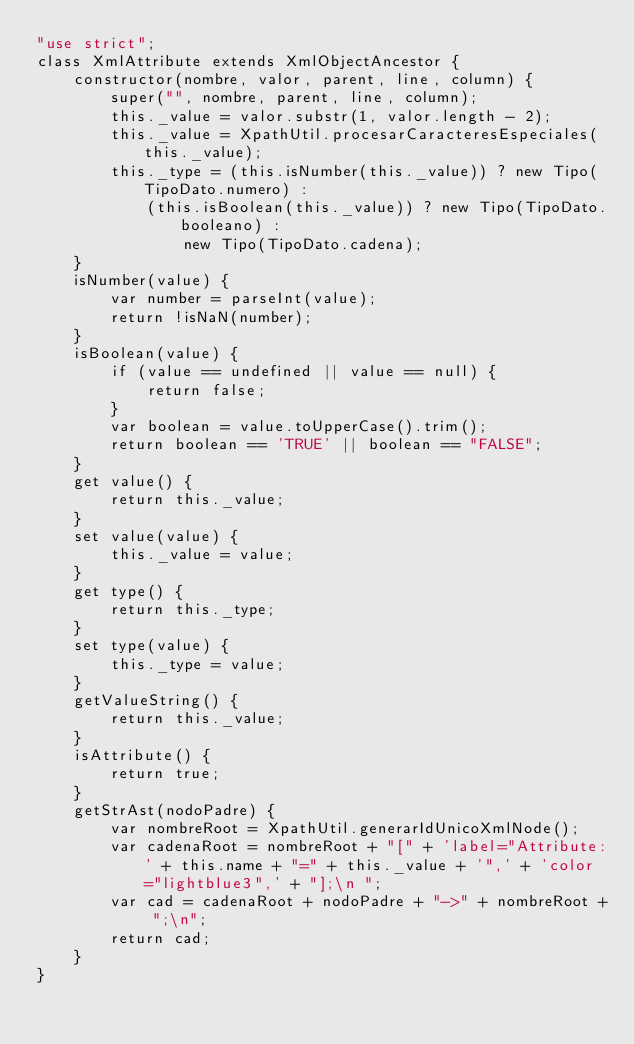<code> <loc_0><loc_0><loc_500><loc_500><_JavaScript_>"use strict";
class XmlAttribute extends XmlObjectAncestor {
    constructor(nombre, valor, parent, line, column) {
        super("", nombre, parent, line, column);
        this._value = valor.substr(1, valor.length - 2);
        this._value = XpathUtil.procesarCaracteresEspeciales(this._value);
        this._type = (this.isNumber(this._value)) ? new Tipo(TipoDato.numero) :
            (this.isBoolean(this._value)) ? new Tipo(TipoDato.booleano) :
                new Tipo(TipoDato.cadena);
    }
    isNumber(value) {
        var number = parseInt(value);
        return !isNaN(number);
    }
    isBoolean(value) {
        if (value == undefined || value == null) {
            return false;
        }
        var boolean = value.toUpperCase().trim();
        return boolean == 'TRUE' || boolean == "FALSE";
    }
    get value() {
        return this._value;
    }
    set value(value) {
        this._value = value;
    }
    get type() {
        return this._type;
    }
    set type(value) {
        this._type = value;
    }
    getValueString() {
        return this._value;
    }
    isAttribute() {
        return true;
    }
    getStrAst(nodoPadre) {
        var nombreRoot = XpathUtil.generarIdUnicoXmlNode();
        var cadenaRoot = nombreRoot + "[" + 'label="Attribute:' + this.name + "=" + this._value + '",' + 'color="lightblue3",' + "];\n ";
        var cad = cadenaRoot + nodoPadre + "->" + nombreRoot + ";\n";
        return cad;
    }
}
</code> 